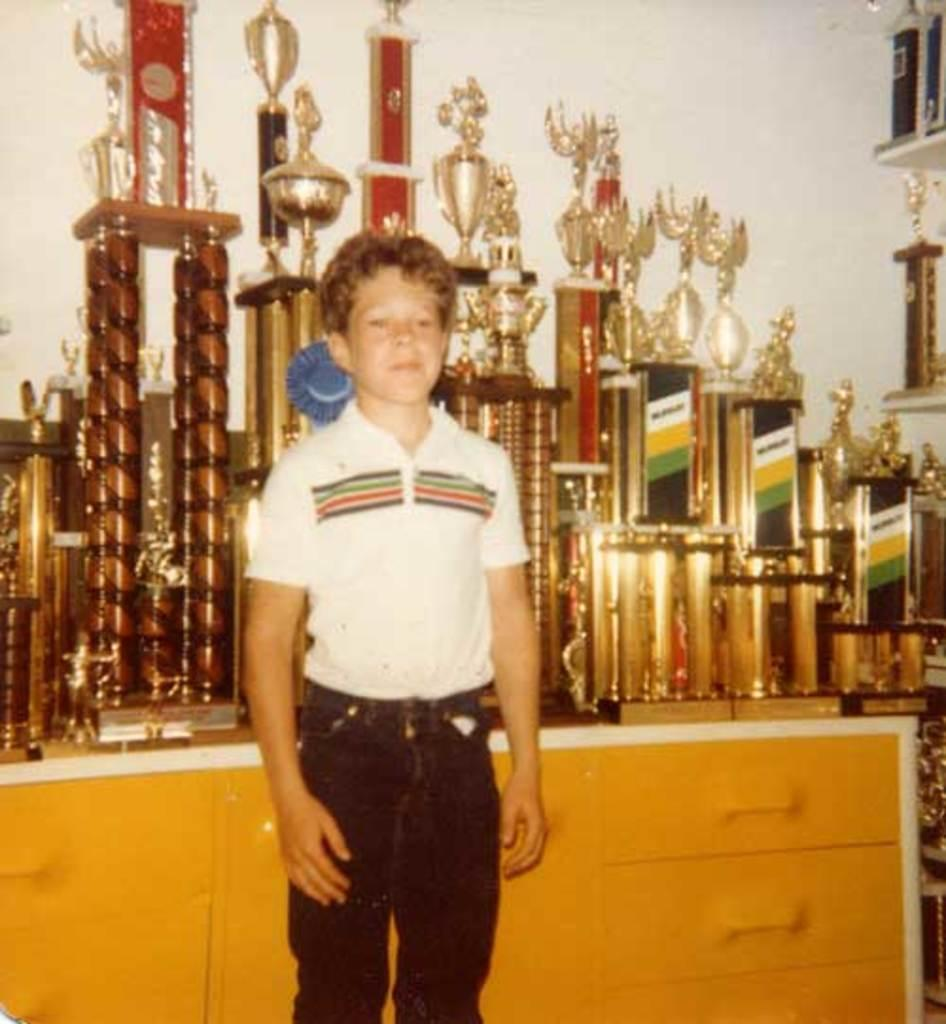Who is the main subject in the image? There is a boy in the image. What is the boy doing in the image? The boy is standing. What is the boy wearing in the image? The boy is wearing a white t-shirt and black jeans. What can be seen in the background of the image? There are trophies and drawers in the background of the image. What type of haircut does the boy have in the image? The provided facts do not mention the boy's haircut, so we cannot determine it from the image. What is the boy using to cover his face in the image? There is no indication in the image that the boy is using anything to cover his face. 